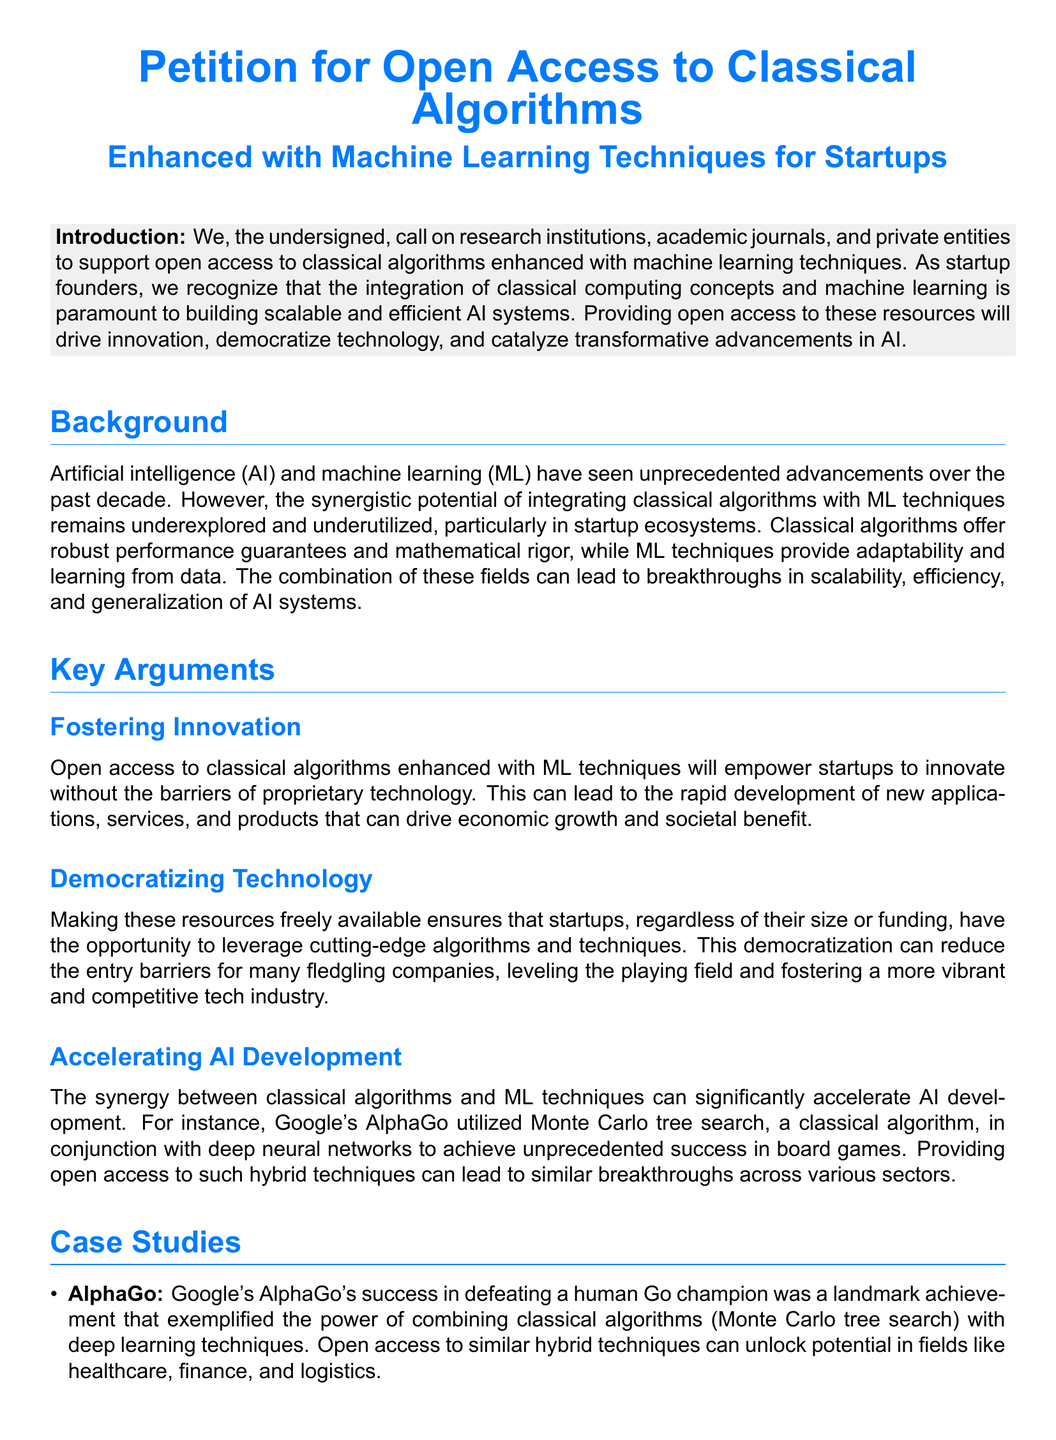What is the main call to action in the petition? The main call to action is for support for open access to classical algorithms enhanced with machine learning techniques.
Answer: Support for open access What is the purpose of providing open access? The purpose is to drive innovation, democratize technology, and catalyze transformative advancements in AI.
Answer: To drive innovation What algorithm did AlphaGo utilize? AlphaGo utilized Monte Carlo tree search.
Answer: Monte Carlo tree search Which sector can benefit from open access according to the petition? The healthcare sector can benefit from open access.
Answer: Healthcare How many case studies are mentioned in the document? There are two case studies mentioned in the document.
Answer: Two What color is used for the titles in the document? The color used for the titles is startup blue.
Answer: Startup blue Who are the primary stakeholders addressed in the petition? The primary stakeholders addressed are research institutions, academic journals, and private entities.
Answer: Research institutions What is one potential application of Shor's algorithm enhanced with ML techniques? One potential application is in cybersecurity.
Answer: Cybersecurity 